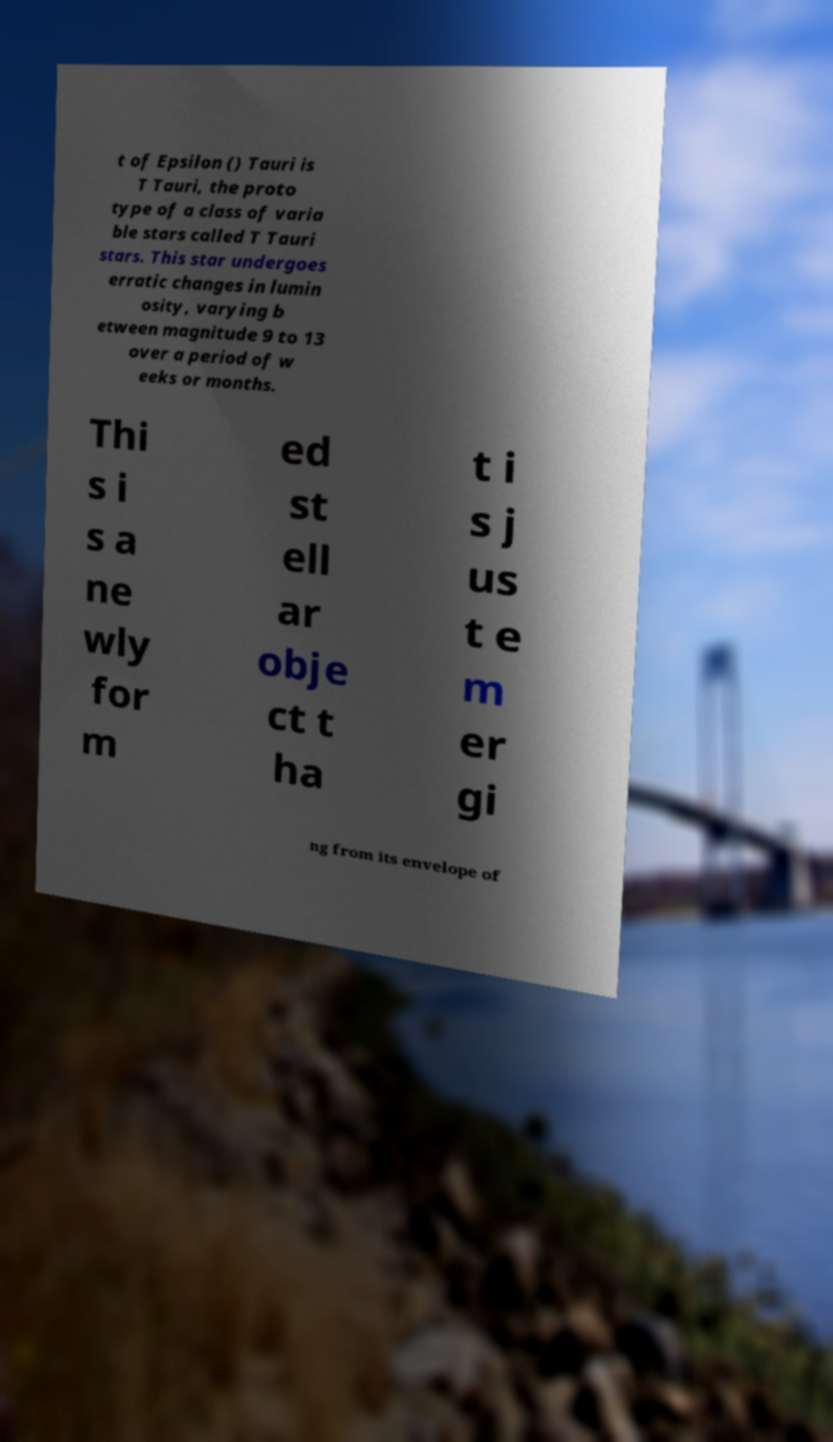There's text embedded in this image that I need extracted. Can you transcribe it verbatim? t of Epsilon () Tauri is T Tauri, the proto type of a class of varia ble stars called T Tauri stars. This star undergoes erratic changes in lumin osity, varying b etween magnitude 9 to 13 over a period of w eeks or months. Thi s i s a ne wly for m ed st ell ar obje ct t ha t i s j us t e m er gi ng from its envelope of 